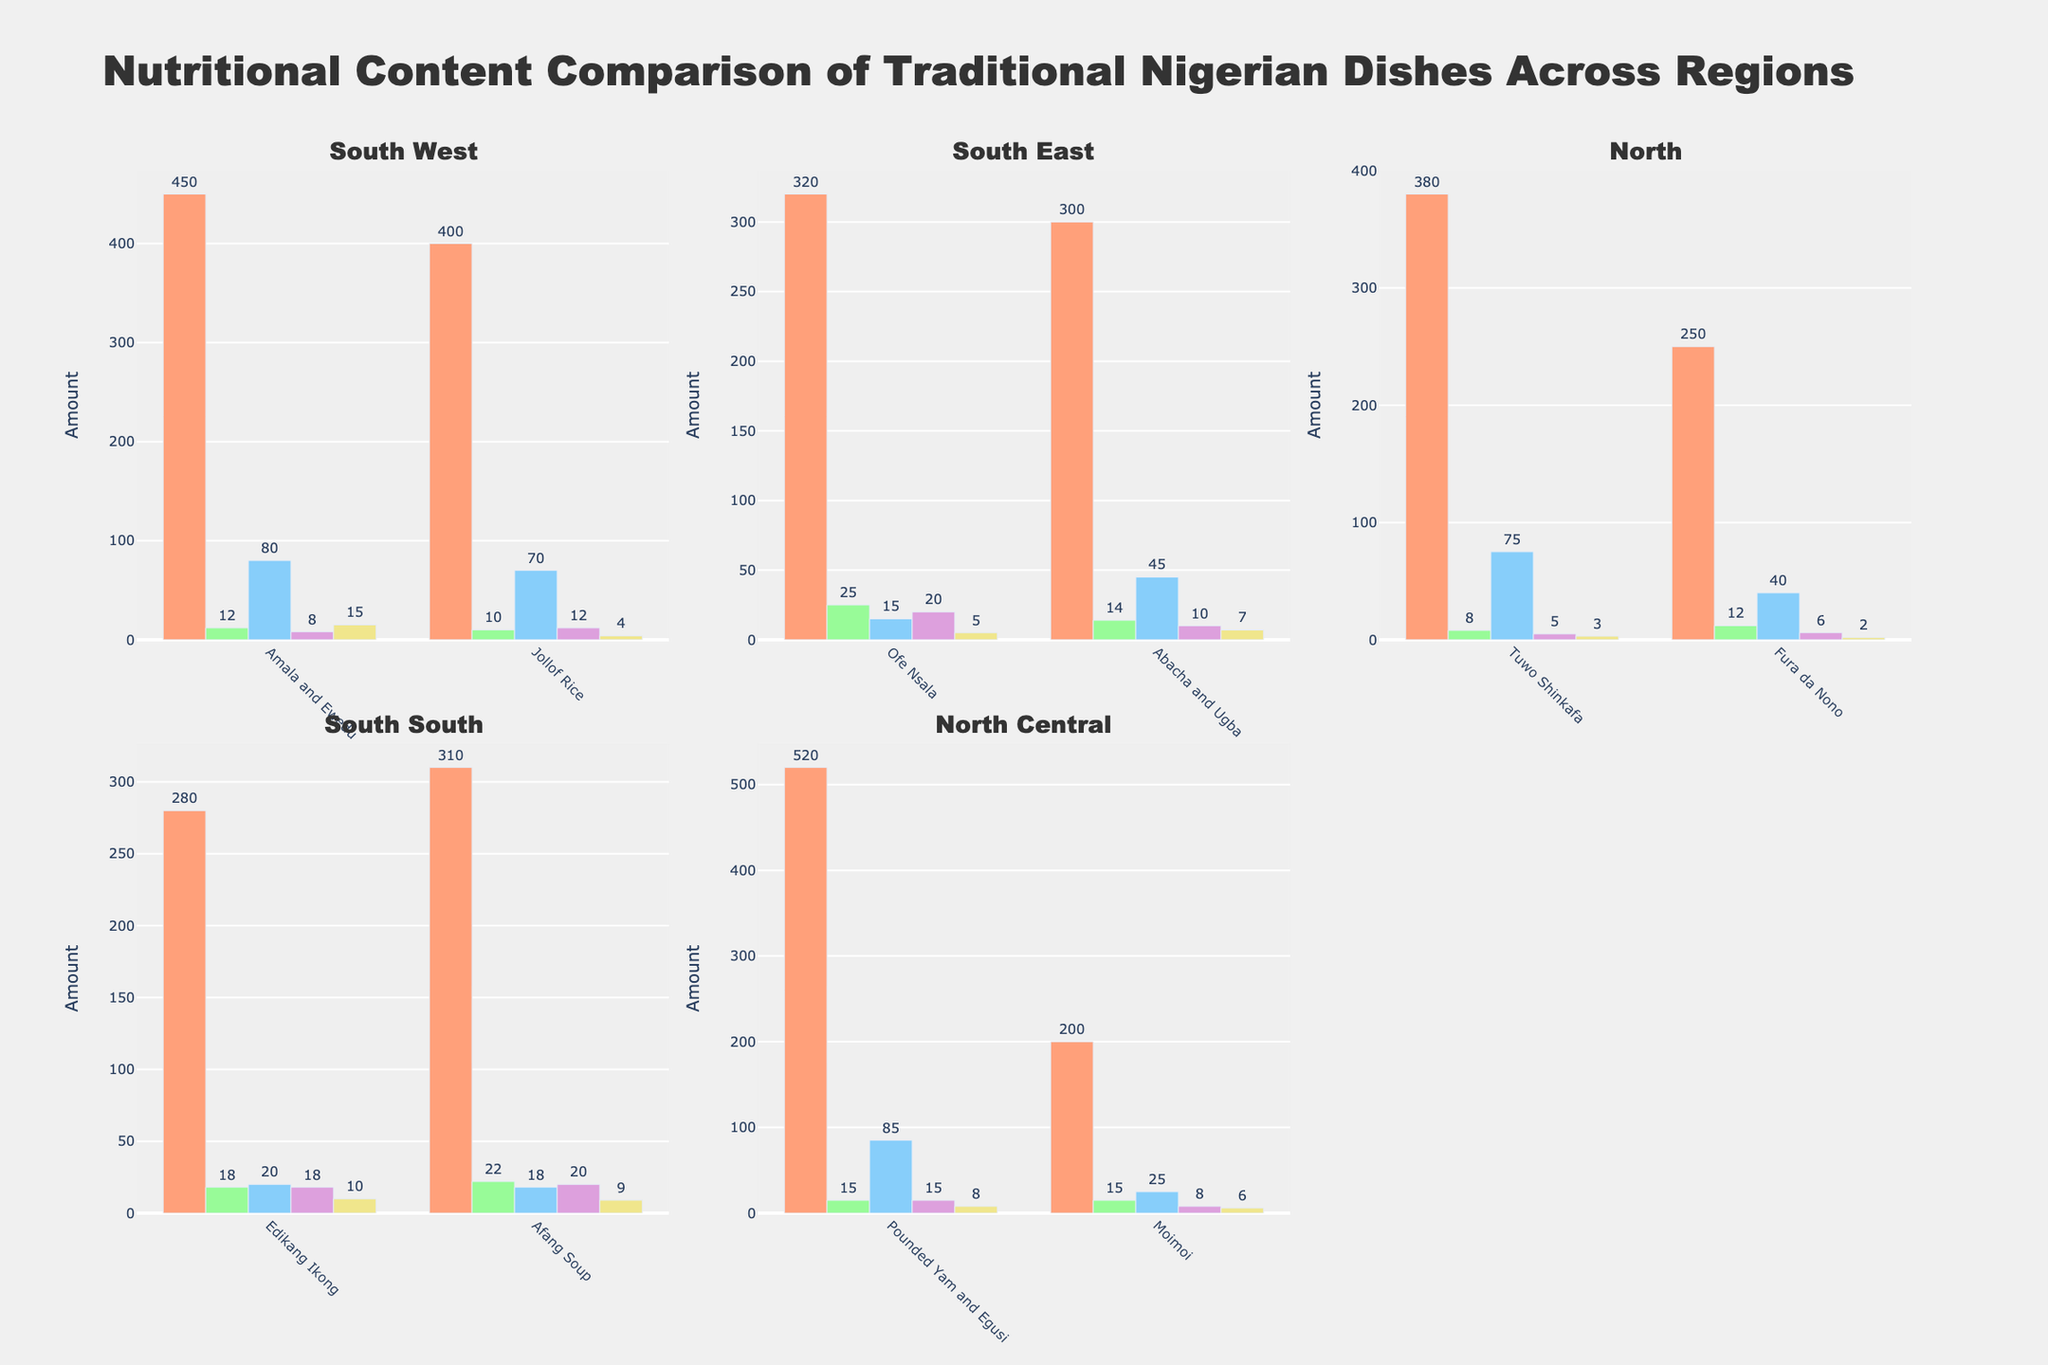Which traditional Nigerian dish has the highest calorie content? By examining the subplots, identify the highest bar in the "Calories" metric across all dishes. Pounded Yam and Egusi in the North Central region has the highest calorie content.
Answer: Pounded Yam and Egusi Which dish from the South West region has more protein, Amala and Ewedu or Jollof Rice? Find the protein values in the South West subplot. Amala and Ewedu has 12 grams of protein, while Jollof Rice has 10 grams.
Answer: Amala and Ewedu Among the dishes in the South East region, which has the highest amount of fat? Look at the "Fat (g)" values in the South East subplot. Ofe Nsala has the highest fat content with 20 grams.
Answer: Ofe Nsala What is the average calorie content of dishes in the North region? Identify the calorie values in the North subplot: Tuwo Shinkafa (380) and Fura da Nono (250). Add these values and divide by 2. (380 + 250) / 2 = 315
Answer: 315 Which dish in the South South region contains more fiber, Edikang Ikong or Afang Soup? Compare the fiber values in the South South subplot: Edikang Ikong has 10 grams of fiber, while Afang Soup has 9 grams.
Answer: Edikang Ikong Which region has the dish with the least amount of carbs? Find the dishes with the least carbs in each subplot. Moimoi in the North Central region has the lowest carbs with 25 grams.
Answer: North Central What's the total amount of protein across all dishes in the South East region? Sum up the protein values of Ofe Nsala (25) and Abacha and Ugba (14) in the South East subplot. 25 + 14 = 39
Answer: 39 How does the fat content of Moimoi compare to the fat content of Jollof Rice? Find the fat values for Moimoi in the North Central subplot (8 grams) and for Jollof Rice in the South West subplot (12 grams). Moimoi has less fat content.
Answer: Moimoi has less fat Which region has more diverse protein content, South South or North Central? Assess the variability in protein values within the subplots. South South has dishes with 18 and 22 grams of protein, while North Central has dishes with 15 and 12 grams, indicating more diversity in the South South region.
Answer: South South How many dishes in the data have at least 70 grams of carbs? Look across all subplots to count the number of dishes with carb values of 70 grams or more. Amala and Ewedu (80), Tuwo Shinkafa (75), Pounded Yam and Egusi (85), and Jollof Rice (70) meet the criteria. There are four dishes.
Answer: 4 